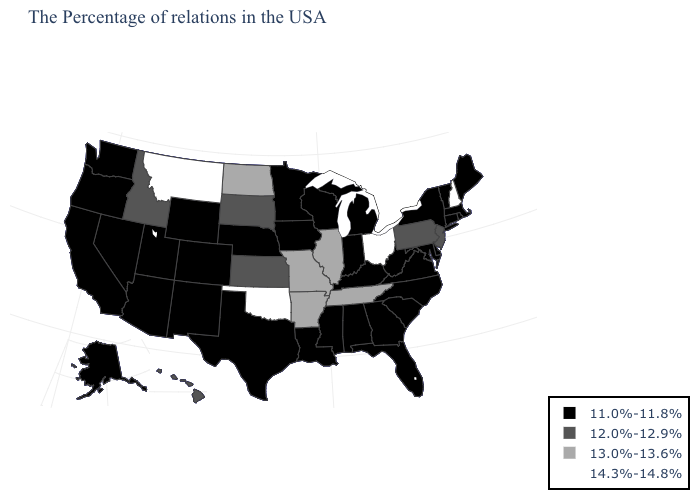What is the value of Missouri?
Concise answer only. 13.0%-13.6%. What is the value of Louisiana?
Concise answer only. 11.0%-11.8%. Which states hav the highest value in the MidWest?
Write a very short answer. Ohio. What is the highest value in the Northeast ?
Write a very short answer. 14.3%-14.8%. Does Pennsylvania have a higher value than Maine?
Concise answer only. Yes. How many symbols are there in the legend?
Concise answer only. 4. Name the states that have a value in the range 12.0%-12.9%?
Give a very brief answer. New Jersey, Pennsylvania, Kansas, South Dakota, Idaho, Hawaii. What is the lowest value in states that border California?
Short answer required. 11.0%-11.8%. Name the states that have a value in the range 13.0%-13.6%?
Give a very brief answer. Tennessee, Illinois, Missouri, Arkansas, North Dakota. Name the states that have a value in the range 11.0%-11.8%?
Keep it brief. Maine, Massachusetts, Rhode Island, Vermont, Connecticut, New York, Delaware, Maryland, Virginia, North Carolina, South Carolina, West Virginia, Florida, Georgia, Michigan, Kentucky, Indiana, Alabama, Wisconsin, Mississippi, Louisiana, Minnesota, Iowa, Nebraska, Texas, Wyoming, Colorado, New Mexico, Utah, Arizona, Nevada, California, Washington, Oregon, Alaska. What is the value of Mississippi?
Quick response, please. 11.0%-11.8%. Name the states that have a value in the range 13.0%-13.6%?
Give a very brief answer. Tennessee, Illinois, Missouri, Arkansas, North Dakota. What is the lowest value in the MidWest?
Concise answer only. 11.0%-11.8%. What is the highest value in the MidWest ?
Write a very short answer. 14.3%-14.8%. What is the highest value in states that border Iowa?
Write a very short answer. 13.0%-13.6%. 